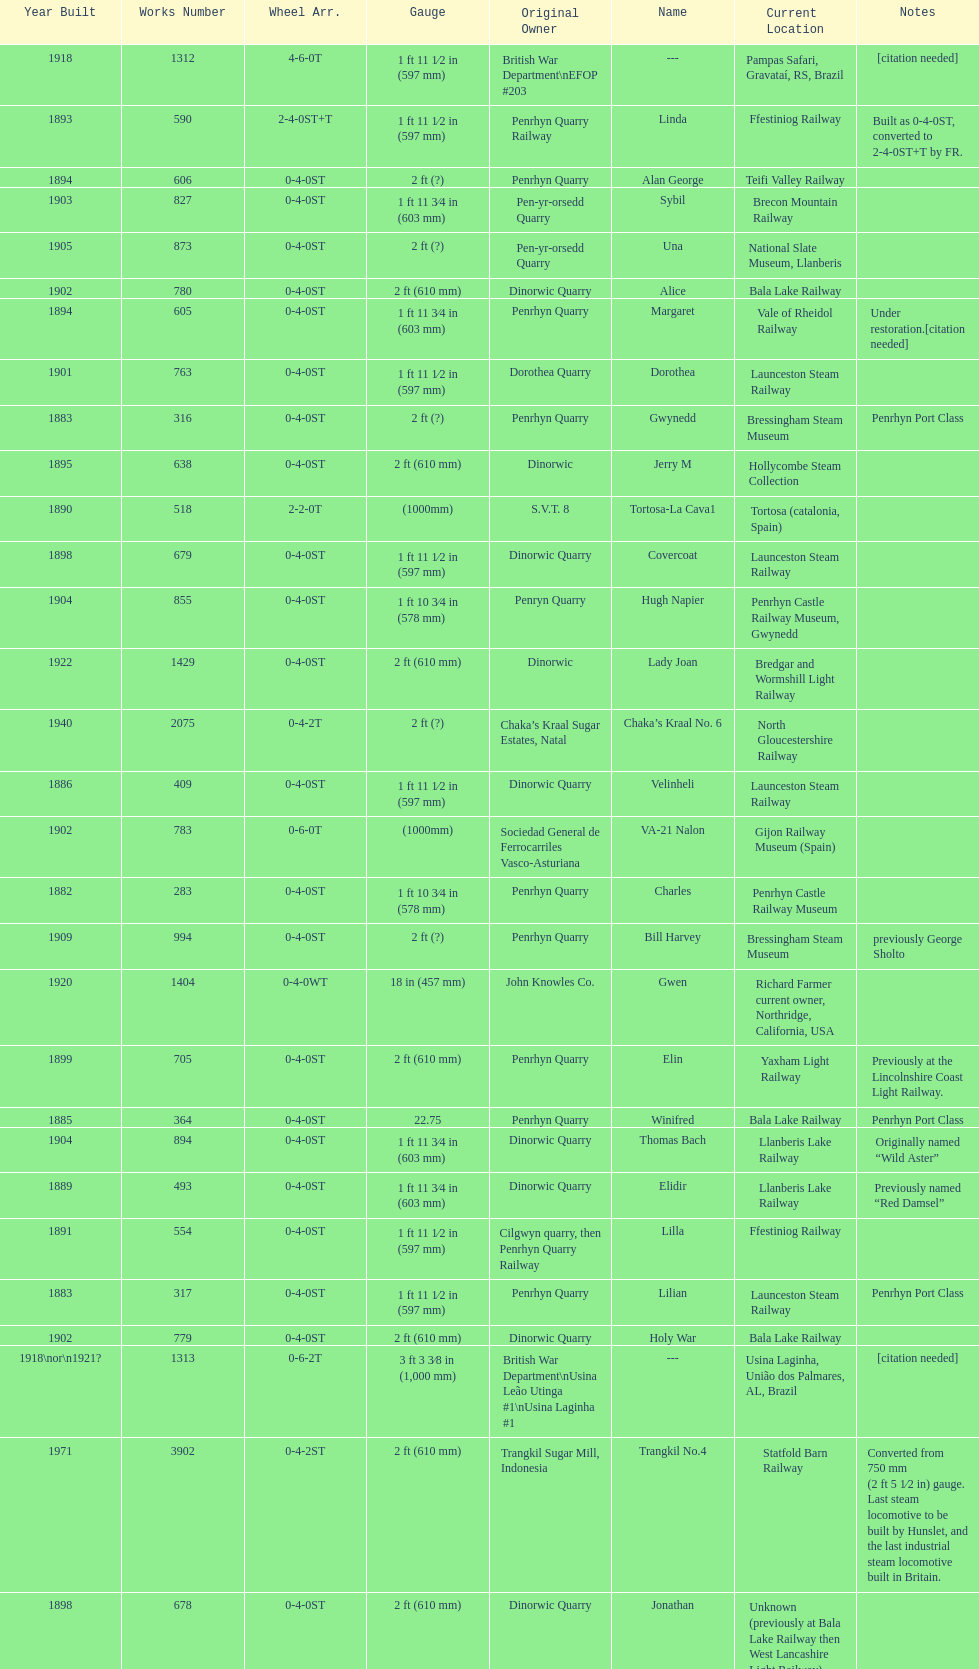Would you be able to parse every entry in this table? {'header': ['Year Built', 'Works Number', 'Wheel Arr.', 'Gauge', 'Original Owner', 'Name', 'Current Location', 'Notes'], 'rows': [['1918', '1312', '4-6-0T', '1\xa0ft\xa011\xa01⁄2\xa0in (597\xa0mm)', 'British War Department\\nEFOP #203', '---', 'Pampas Safari, Gravataí, RS, Brazil', '[citation needed]'], ['1893', '590', '2-4-0ST+T', '1\xa0ft 11\xa01⁄2\xa0in (597\xa0mm)', 'Penrhyn Quarry Railway', 'Linda', 'Ffestiniog Railway', 'Built as 0-4-0ST, converted to 2-4-0ST+T by FR.'], ['1894', '606', '0-4-0ST', '2\xa0ft (?)', 'Penrhyn Quarry', 'Alan George', 'Teifi Valley Railway', ''], ['1903', '827', '0-4-0ST', '1\xa0ft 11\xa03⁄4\xa0in (603\xa0mm)', 'Pen-yr-orsedd Quarry', 'Sybil', 'Brecon Mountain Railway', ''], ['1905', '873', '0-4-0ST', '2\xa0ft (?)', 'Pen-yr-orsedd Quarry', 'Una', 'National Slate Museum, Llanberis', ''], ['1902', '780', '0-4-0ST', '2\xa0ft (610\xa0mm)', 'Dinorwic Quarry', 'Alice', 'Bala Lake Railway', ''], ['1894', '605', '0-4-0ST', '1\xa0ft 11\xa03⁄4\xa0in (603\xa0mm)', 'Penrhyn Quarry', 'Margaret', 'Vale of Rheidol Railway', 'Under restoration.[citation needed]'], ['1901', '763', '0-4-0ST', '1\xa0ft 11\xa01⁄2\xa0in (597\xa0mm)', 'Dorothea Quarry', 'Dorothea', 'Launceston Steam Railway', ''], ['1883', '316', '0-4-0ST', '2\xa0ft (?)', 'Penrhyn Quarry', 'Gwynedd', 'Bressingham Steam Museum', 'Penrhyn Port Class'], ['1895', '638', '0-4-0ST', '2\xa0ft (610\xa0mm)', 'Dinorwic', 'Jerry M', 'Hollycombe Steam Collection', ''], ['1890', '518', '2-2-0T', '(1000mm)', 'S.V.T. 8', 'Tortosa-La Cava1', 'Tortosa (catalonia, Spain)', ''], ['1898', '679', '0-4-0ST', '1\xa0ft 11\xa01⁄2\xa0in (597\xa0mm)', 'Dinorwic Quarry', 'Covercoat', 'Launceston Steam Railway', ''], ['1904', '855', '0-4-0ST', '1\xa0ft 10\xa03⁄4\xa0in (578\xa0mm)', 'Penryn Quarry', 'Hugh Napier', 'Penrhyn Castle Railway Museum, Gwynedd', ''], ['1922', '1429', '0-4-0ST', '2\xa0ft (610\xa0mm)', 'Dinorwic', 'Lady Joan', 'Bredgar and Wormshill Light Railway', ''], ['1940', '2075', '0-4-2T', '2\xa0ft (?)', 'Chaka’s Kraal Sugar Estates, Natal', 'Chaka’s Kraal No. 6', 'North Gloucestershire Railway', ''], ['1886', '409', '0-4-0ST', '1\xa0ft 11\xa01⁄2\xa0in (597\xa0mm)', 'Dinorwic Quarry', 'Velinheli', 'Launceston Steam Railway', ''], ['1902', '783', '0-6-0T', '(1000mm)', 'Sociedad General de Ferrocarriles Vasco-Asturiana', 'VA-21 Nalon', 'Gijon Railway Museum (Spain)', ''], ['1882', '283', '0-4-0ST', '1\xa0ft 10\xa03⁄4\xa0in (578\xa0mm)', 'Penrhyn Quarry', 'Charles', 'Penrhyn Castle Railway Museum', ''], ['1909', '994', '0-4-0ST', '2\xa0ft (?)', 'Penrhyn Quarry', 'Bill Harvey', 'Bressingham Steam Museum', 'previously George Sholto'], ['1920', '1404', '0-4-0WT', '18\xa0in (457\xa0mm)', 'John Knowles Co.', 'Gwen', 'Richard Farmer current owner, Northridge, California, USA', ''], ['1899', '705', '0-4-0ST', '2\xa0ft (610\xa0mm)', 'Penrhyn Quarry', 'Elin', 'Yaxham Light Railway', 'Previously at the Lincolnshire Coast Light Railway.'], ['1885', '364', '0-4-0ST', '22.75', 'Penrhyn Quarry', 'Winifred', 'Bala Lake Railway', 'Penrhyn Port Class'], ['1904', '894', '0-4-0ST', '1\xa0ft 11\xa03⁄4\xa0in (603\xa0mm)', 'Dinorwic Quarry', 'Thomas Bach', 'Llanberis Lake Railway', 'Originally named “Wild Aster”'], ['1889', '493', '0-4-0ST', '1\xa0ft 11\xa03⁄4\xa0in (603\xa0mm)', 'Dinorwic Quarry', 'Elidir', 'Llanberis Lake Railway', 'Previously named “Red Damsel”'], ['1891', '554', '0-4-0ST', '1\xa0ft 11\xa01⁄2\xa0in (597\xa0mm)', 'Cilgwyn quarry, then Penrhyn Quarry Railway', 'Lilla', 'Ffestiniog Railway', ''], ['1883', '317', '0-4-0ST', '1\xa0ft 11\xa01⁄2\xa0in (597\xa0mm)', 'Penrhyn Quarry', 'Lilian', 'Launceston Steam Railway', 'Penrhyn Port Class'], ['1902', '779', '0-4-0ST', '2\xa0ft (610\xa0mm)', 'Dinorwic Quarry', 'Holy War', 'Bala Lake Railway', ''], ['1918\\nor\\n1921?', '1313', '0-6-2T', '3\xa0ft\xa03\xa03⁄8\xa0in (1,000\xa0mm)', 'British War Department\\nUsina Leão Utinga #1\\nUsina Laginha #1', '---', 'Usina Laginha, União dos Palmares, AL, Brazil', '[citation needed]'], ['1971', '3902', '0-4-2ST', '2\xa0ft (610\xa0mm)', 'Trangkil Sugar Mill, Indonesia', 'Trangkil No.4', 'Statfold Barn Railway', 'Converted from 750\xa0mm (2\xa0ft\xa05\xa01⁄2\xa0in) gauge. Last steam locomotive to be built by Hunslet, and the last industrial steam locomotive built in Britain.'], ['1898', '678', '0-4-0ST', '2\xa0ft (610\xa0mm)', 'Dinorwic Quarry', 'Jonathan', 'Unknown (previously at Bala Lake Railway then West Lancashire Light Railway)', ''], ['1891', '542', '0-4-0ST', '2\xa0ft (610\xa0mm)', 'Dinorwic Quarry', 'Cloister', 'Purbeck Mineral & Mining Museum', 'Owned by Hampshire Narrow Gauge Railway Trust, previously at Kew Bridge Steam Museum and Amberley'], ['1891', '541', '0-4-0ST', '1\xa0ft 10\xa03⁄4\xa0in (578\xa0mm)', 'Dinorwic Quarry', 'Rough Pup', 'Narrow Gauge Railway Museum, Tywyn', ''], ['1906', '920', '0-4-0ST', '2\xa0ft (?)', 'Penrhyn Quarry', 'Pamela', 'Old Kiln Light Railway', ''], ['1903', '822', '0-4-0ST', '2\xa0ft (610\xa0mm)', 'Dinorwic Quarry', 'Maid Marian', 'Bala Lake Railway', ''], ['1954', '3815', '2-6-2T', '2\xa0ft 6\xa0in (762\xa0mm)', 'Sierra Leone Government Railway', '14', 'Welshpool and Llanfair Light Railway', ''], ['1893', '589', '2-4-0ST+T', '1\xa0ft 11\xa01⁄2\xa0in (597\xa0mm)', 'Penrhyn Quarry Railway', 'Blanche', 'Ffestiniog Railway', 'Built as 0-4-0ST, converted to 2-4-0ST+T by FR.'], ['1906', '901', '2-6-2T', '1\xa0ft 11\xa01⁄2\xa0in (597\xa0mm)', 'North Wales Narrow Gauge Railways', 'Russell', 'Welsh Highland Heritage Railway', ''], ['1903', '823', '0-4-0ST', '2\xa0ft (?)', 'Dinorwic Quarry', 'Irish Mail', 'West Lancashire Light Railway', ''], ['1896', '652', '0-4-0ST', '1\xa0ft 11\xa01⁄2\xa0in (597\xa0mm)', 'Groby Granite, then Dinorwic Quarry', 'Lady Madcap', 'Welsh Highland Heritage Railway', 'Originally named Sextus.'], ['1922', '1430', '0-4-0ST', '1\xa0ft 11\xa03⁄4\xa0in (603\xa0mm)', 'Dinorwic Quarry', 'Dolbadarn', 'Llanberis Lake Railway', ''], ['1898', '684', '0-4-0WT', '18\xa0in (457\xa0mm)', 'John Knowles Co.', 'Jack', 'Armley Mills Industrial Museum, Leeds', ''], ['1937', '1859', '0-4-2T', '2\xa0ft (?)', 'Umtwalumi Valley Estate, Natal', '16 Carlisle', 'South Tynedale Railway', ''], ['1899', '707', '0-4-0ST', '1\xa0ft 11\xa01⁄2\xa0in (597\xa0mm)', 'Pen-yr-orsedd Quarry', 'Britomart', 'Ffestiniog Railway', ''], ['1898', '680', '0-4-0ST', '2\xa0ft (610\xa0mm)', 'Dinorwic Quarry', 'George B', 'Bala Lake Railway', '']]} Which works number had a larger gauge, 283 or 317? 317. 